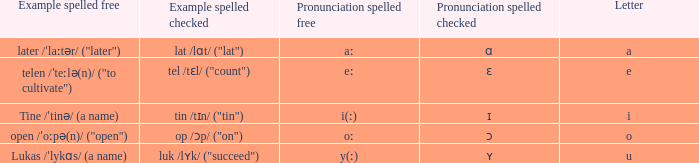What is Pronunciation Spelled Free, when Pronunciation Spelled Checked is "ɑ"? Aː. 